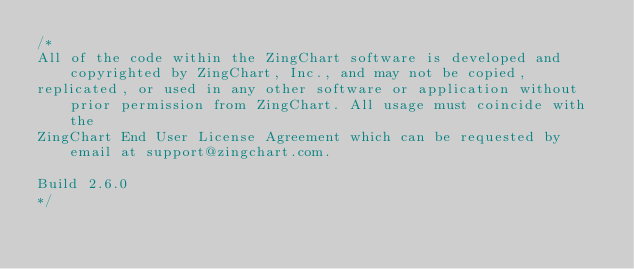Convert code to text. <code><loc_0><loc_0><loc_500><loc_500><_JavaScript_>/*
All of the code within the ZingChart software is developed and copyrighted by ZingChart, Inc., and may not be copied,
replicated, or used in any other software or application without prior permission from ZingChart. All usage must coincide with the
ZingChart End User License Agreement which can be requested by email at support@zingchart.com.

Build 2.6.0
*/</code> 